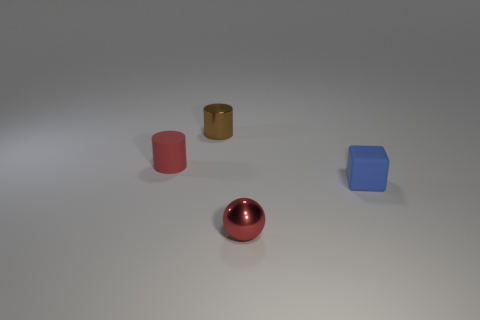Does the cube have the same color as the thing that is in front of the small matte block?
Provide a short and direct response. No. What is the object that is both on the left side of the blue thing and right of the small brown shiny thing made of?
Provide a succinct answer. Metal. There is a rubber cylinder that is the same color as the small sphere; what is its size?
Provide a succinct answer. Small. Is the shape of the small rubber object left of the small blue cube the same as the metal thing that is in front of the small rubber cylinder?
Give a very brief answer. No. Is there a small blue shiny thing?
Give a very brief answer. No. What is the color of the tiny metallic object that is the same shape as the red matte thing?
Your response must be concise. Brown. What color is the rubber cylinder that is the same size as the sphere?
Ensure brevity in your answer.  Red. Is the material of the small cube the same as the small red ball?
Offer a terse response. No. What number of objects have the same color as the small shiny ball?
Offer a terse response. 1. Is the metallic cylinder the same color as the tiny matte cylinder?
Provide a succinct answer. No. 